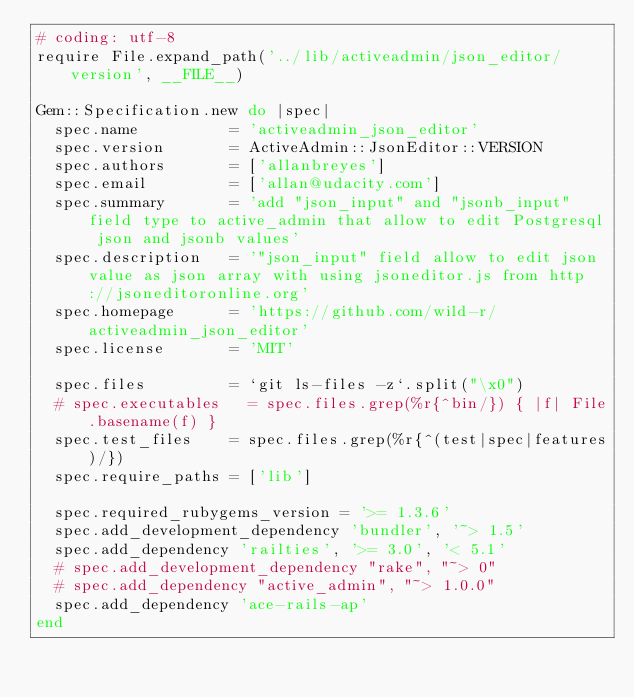Convert code to text. <code><loc_0><loc_0><loc_500><loc_500><_Ruby_># coding: utf-8
require File.expand_path('../lib/activeadmin/json_editor/version', __FILE__)

Gem::Specification.new do |spec|
  spec.name          = 'activeadmin_json_editor'
  spec.version       = ActiveAdmin::JsonEditor::VERSION
  spec.authors       = ['allanbreyes']
  spec.email         = ['allan@udacity.com']
  spec.summary       = 'add "json_input" and "jsonb_input" field type to active_admin that allow to edit Postgresql json and jsonb values'
  spec.description   = '"json_input" field allow to edit json value as json array with using jsoneditor.js from http://jsoneditoronline.org'
  spec.homepage      = 'https://github.com/wild-r/activeadmin_json_editor'
  spec.license       = 'MIT'

  spec.files         = `git ls-files -z`.split("\x0")
  # spec.executables   = spec.files.grep(%r{^bin/}) { |f| File.basename(f) }
  spec.test_files    = spec.files.grep(%r{^(test|spec|features)/})
  spec.require_paths = ['lib']

  spec.required_rubygems_version = '>= 1.3.6'
  spec.add_development_dependency 'bundler', '~> 1.5'
  spec.add_dependency 'railties', '>= 3.0', '< 5.1'
  # spec.add_development_dependency "rake", "~> 0"
  # spec.add_dependency "active_admin", "~> 1.0.0"
  spec.add_dependency 'ace-rails-ap'
end
</code> 